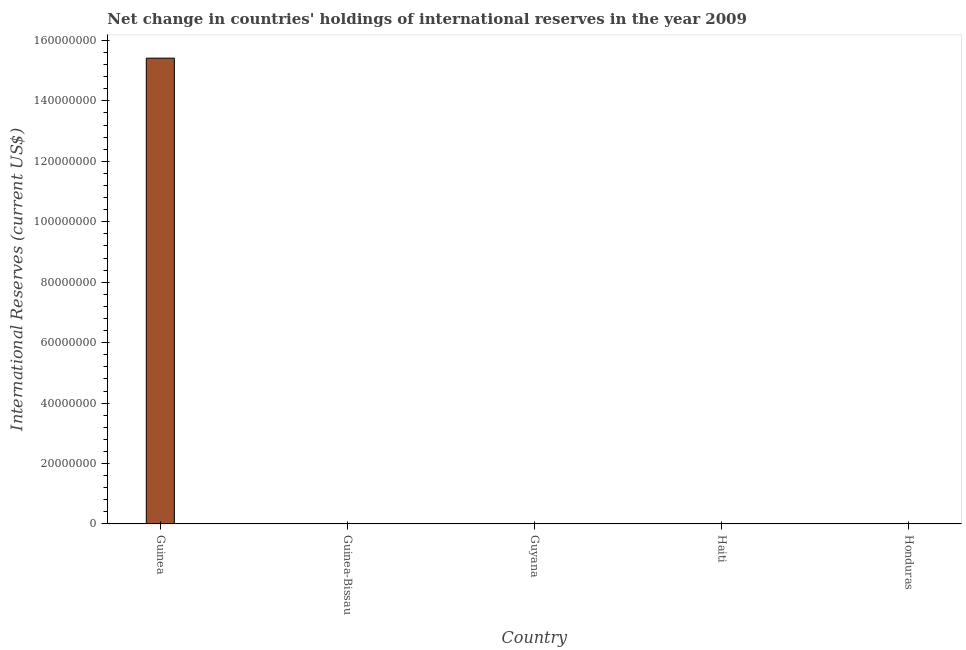Does the graph contain any zero values?
Your response must be concise. Yes. What is the title of the graph?
Offer a very short reply. Net change in countries' holdings of international reserves in the year 2009. What is the label or title of the Y-axis?
Provide a succinct answer. International Reserves (current US$). What is the reserves and related items in Guinea?
Provide a short and direct response. 1.54e+08. Across all countries, what is the maximum reserves and related items?
Your response must be concise. 1.54e+08. Across all countries, what is the minimum reserves and related items?
Keep it short and to the point. 0. In which country was the reserves and related items maximum?
Provide a short and direct response. Guinea. What is the sum of the reserves and related items?
Your answer should be very brief. 1.54e+08. What is the average reserves and related items per country?
Ensure brevity in your answer.  3.08e+07. What is the median reserves and related items?
Your answer should be very brief. 0. In how many countries, is the reserves and related items greater than 152000000 US$?
Your response must be concise. 1. What is the difference between the highest and the lowest reserves and related items?
Offer a terse response. 1.54e+08. In how many countries, is the reserves and related items greater than the average reserves and related items taken over all countries?
Your answer should be very brief. 1. How many bars are there?
Give a very brief answer. 1. Are all the bars in the graph horizontal?
Give a very brief answer. No. How many countries are there in the graph?
Provide a short and direct response. 5. Are the values on the major ticks of Y-axis written in scientific E-notation?
Provide a succinct answer. No. What is the International Reserves (current US$) in Guinea?
Your response must be concise. 1.54e+08. What is the International Reserves (current US$) of Haiti?
Make the answer very short. 0. What is the International Reserves (current US$) of Honduras?
Give a very brief answer. 0. 